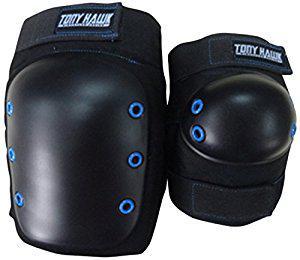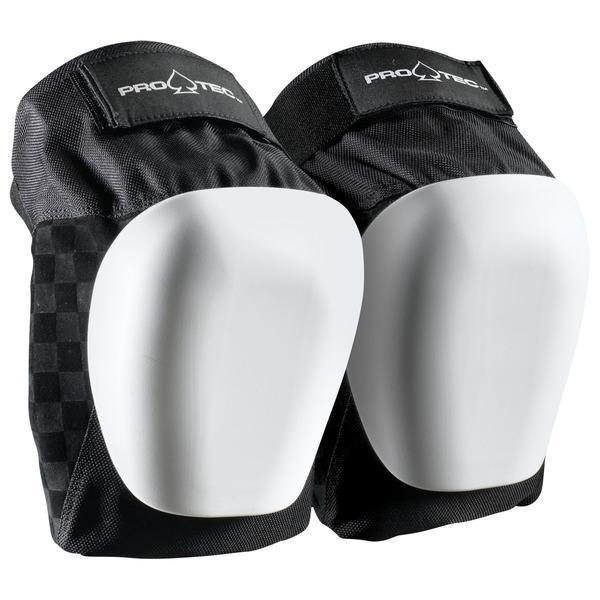The first image is the image on the left, the second image is the image on the right. Evaluate the accuracy of this statement regarding the images: "There are two kneepads with solid red writing across the top of the knee pad.". Is it true? Answer yes or no. No. 